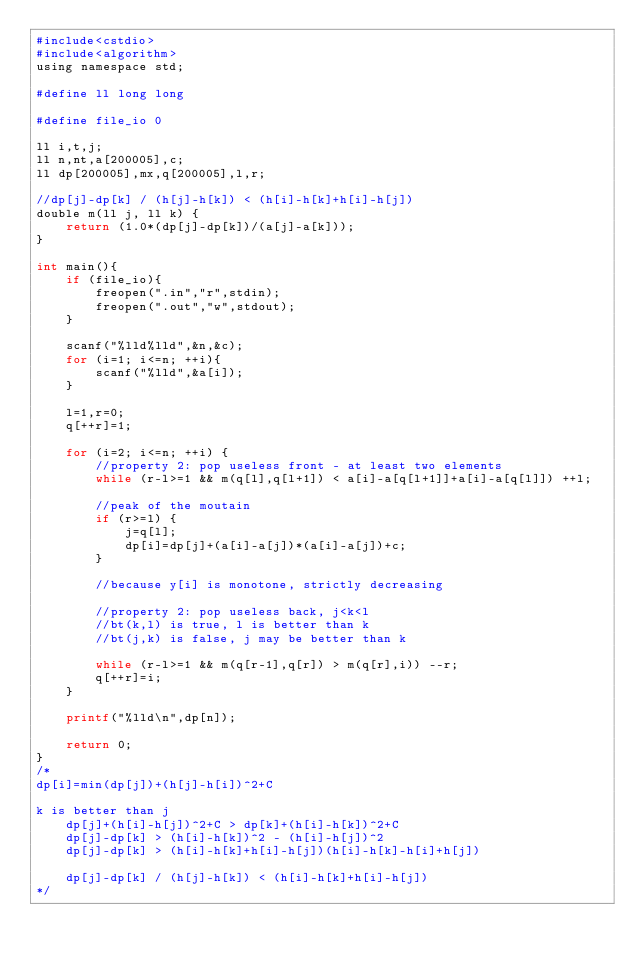<code> <loc_0><loc_0><loc_500><loc_500><_Awk_>#include<cstdio>
#include<algorithm>
using namespace std;

#define ll long long 

#define file_io 0

ll i,t,j;
ll n,nt,a[200005],c;
ll dp[200005],mx,q[200005],l,r;

//dp[j]-dp[k] / (h[j]-h[k]) < (h[i]-h[k]+h[i]-h[j])
double m(ll j, ll k) {
	return (1.0*(dp[j]-dp[k])/(a[j]-a[k]));
}

int main(){
	if (file_io){
		freopen(".in","r",stdin);
		freopen(".out","w",stdout);
	}
	
	scanf("%lld%lld",&n,&c);
	for (i=1; i<=n; ++i){
		scanf("%lld",&a[i]);
	}
	
	l=1,r=0;
	q[++r]=1;

	for (i=2; i<=n; ++i) {
		//property 2: pop useless front - at least two elements
		while (r-l>=1 && m(q[l],q[l+1]) < a[i]-a[q[l+1]]+a[i]-a[q[l]]) ++l;

		//peak of the moutain
		if (r>=l) {
			j=q[l];
			dp[i]=dp[j]+(a[i]-a[j])*(a[i]-a[j])+c;
		}

		//because y[i] is monotone, strictly decreasing
		
		//property 2: pop useless back, j<k<l
		//bt(k,l) is true, l is better than k
		//bt(j,k) is false, j may be better than k

		while (r-l>=1 && m(q[r-1],q[r]) > m(q[r],i)) --r;
		q[++r]=i;
	}

	printf("%lld\n",dp[n]);
	
	return 0;
}
/*
dp[i]=min(dp[j])+(h[j]-h[i])^2+C

k is better than j
	dp[j]+(h[i]-h[j])^2+C > dp[k]+(h[i]-h[k])^2+C
	dp[j]-dp[k] > (h[i]-h[k])^2 - (h[i]-h[j])^2
	dp[j]-dp[k] > (h[i]-h[k]+h[i]-h[j])(h[i]-h[k]-h[i]+h[j])
	
	dp[j]-dp[k] / (h[j]-h[k]) < (h[i]-h[k]+h[i]-h[j])
*/</code> 